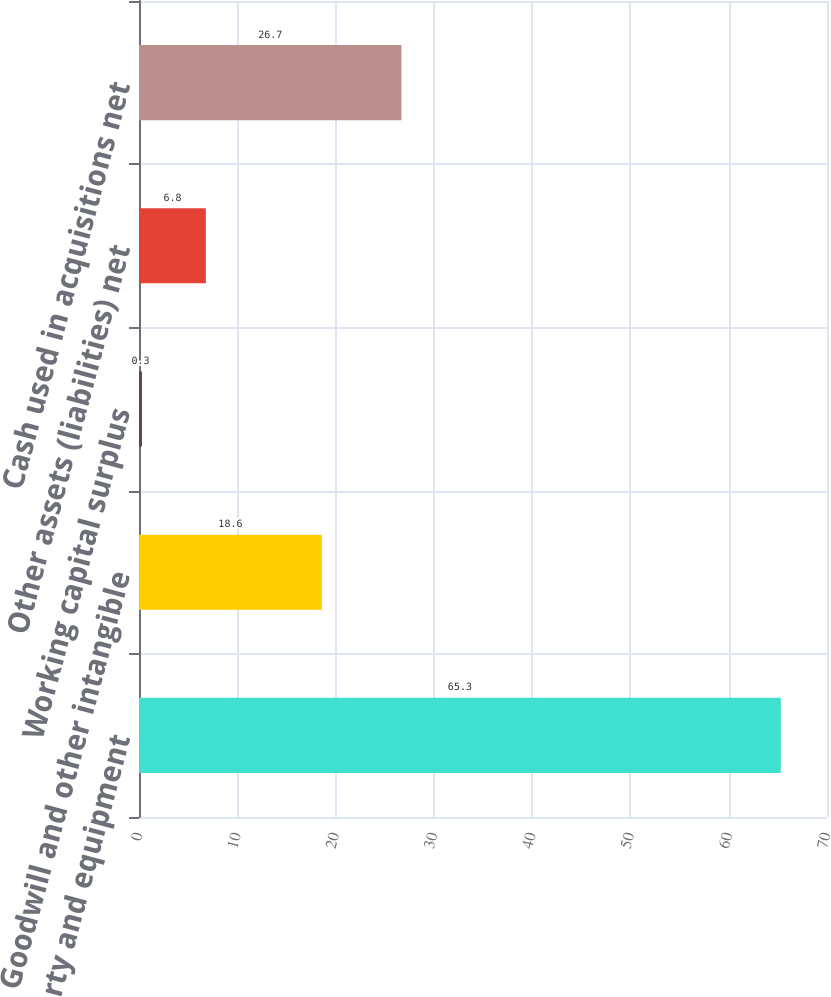Convert chart to OTSL. <chart><loc_0><loc_0><loc_500><loc_500><bar_chart><fcel>Property and equipment<fcel>Goodwill and other intangible<fcel>Working capital surplus<fcel>Other assets (liabilities) net<fcel>Cash used in acquisitions net<nl><fcel>65.3<fcel>18.6<fcel>0.3<fcel>6.8<fcel>26.7<nl></chart> 